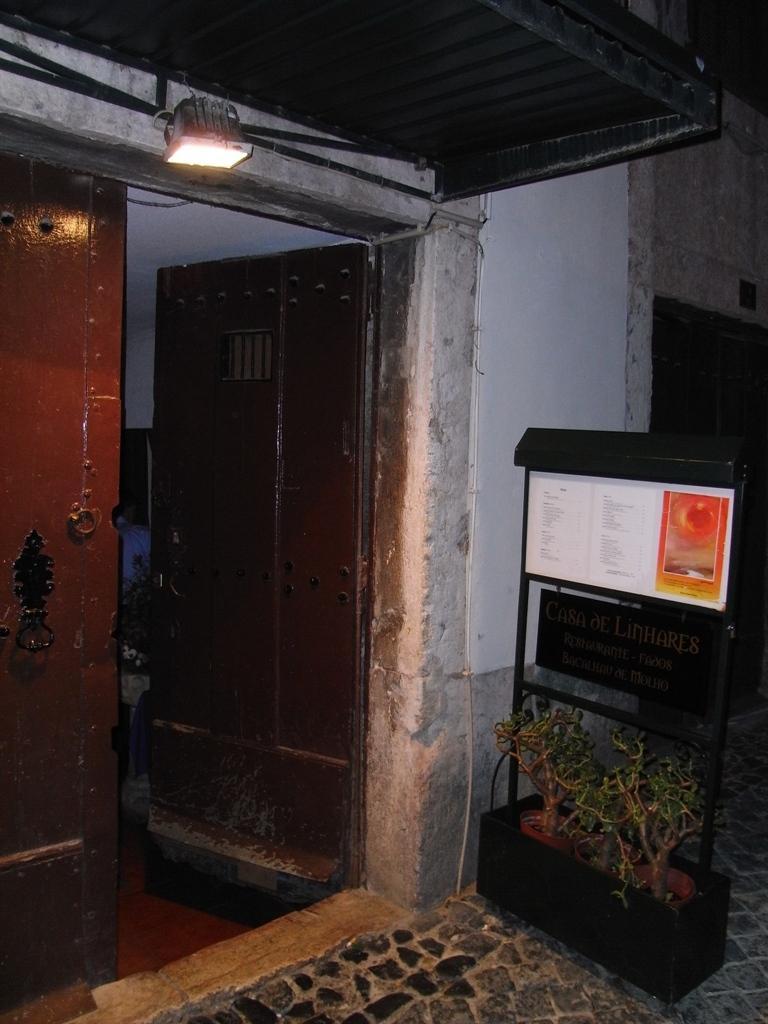How would you summarize this image in a sentence or two? On the left side of the image we can see door, electric light on the top of the door and a houseplant. On the left side of the image we can see an advertisement, name plate and house plants on the floor. 